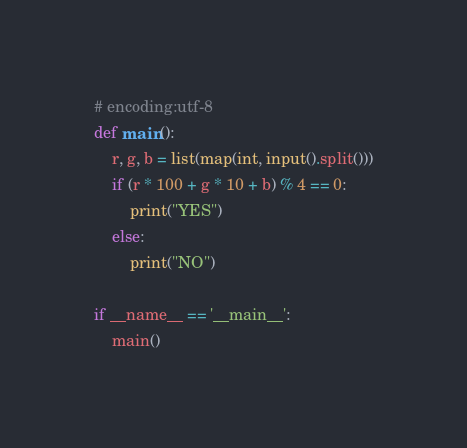<code> <loc_0><loc_0><loc_500><loc_500><_Python_># encoding:utf-8
def main():
	r, g, b = list(map(int, input().split()))
	if (r * 100 + g * 10 + b) % 4 == 0:
		print("YES")
	else:
		print("NO")
	
if __name__ == '__main__':
	main()</code> 